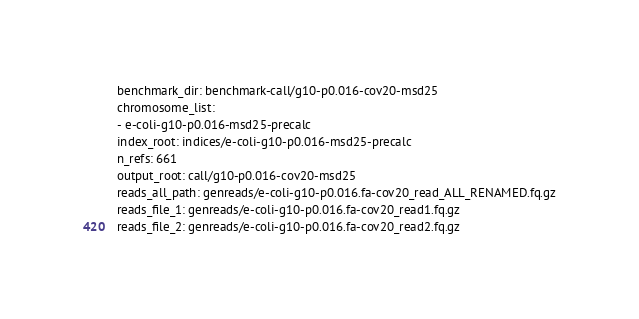<code> <loc_0><loc_0><loc_500><loc_500><_YAML_>benchmark_dir: benchmark-call/g10-p0.016-cov20-msd25
chromosome_list:
- e-coli-g10-p0.016-msd25-precalc
index_root: indices/e-coli-g10-p0.016-msd25-precalc
n_refs: 661
output_root: call/g10-p0.016-cov20-msd25
reads_all_path: genreads/e-coli-g10-p0.016.fa-cov20_read_ALL_RENAMED.fq.gz
reads_file_1: genreads/e-coli-g10-p0.016.fa-cov20_read1.fq.gz
reads_file_2: genreads/e-coli-g10-p0.016.fa-cov20_read2.fq.gz
</code> 